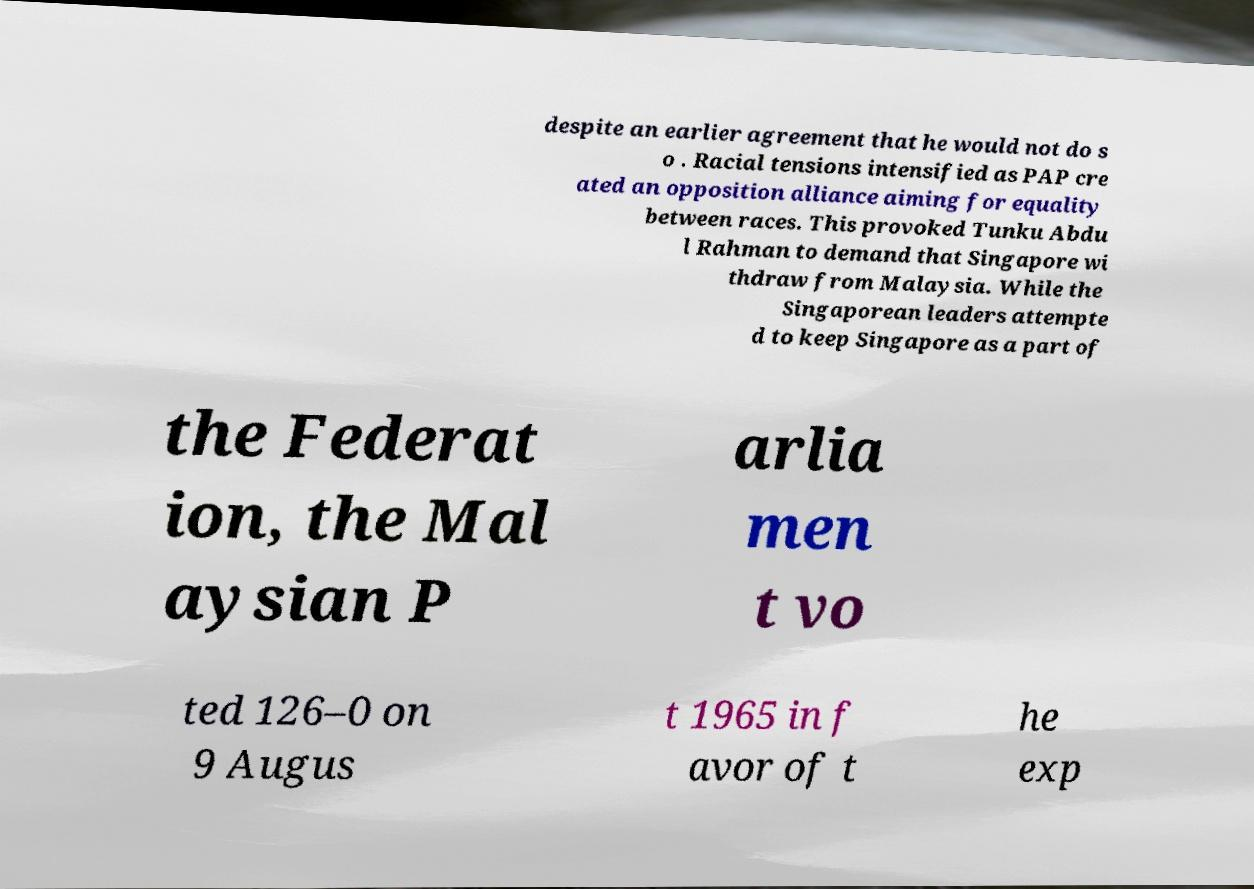I need the written content from this picture converted into text. Can you do that? despite an earlier agreement that he would not do s o . Racial tensions intensified as PAP cre ated an opposition alliance aiming for equality between races. This provoked Tunku Abdu l Rahman to demand that Singapore wi thdraw from Malaysia. While the Singaporean leaders attempte d to keep Singapore as a part of the Federat ion, the Mal aysian P arlia men t vo ted 126–0 on 9 Augus t 1965 in f avor of t he exp 